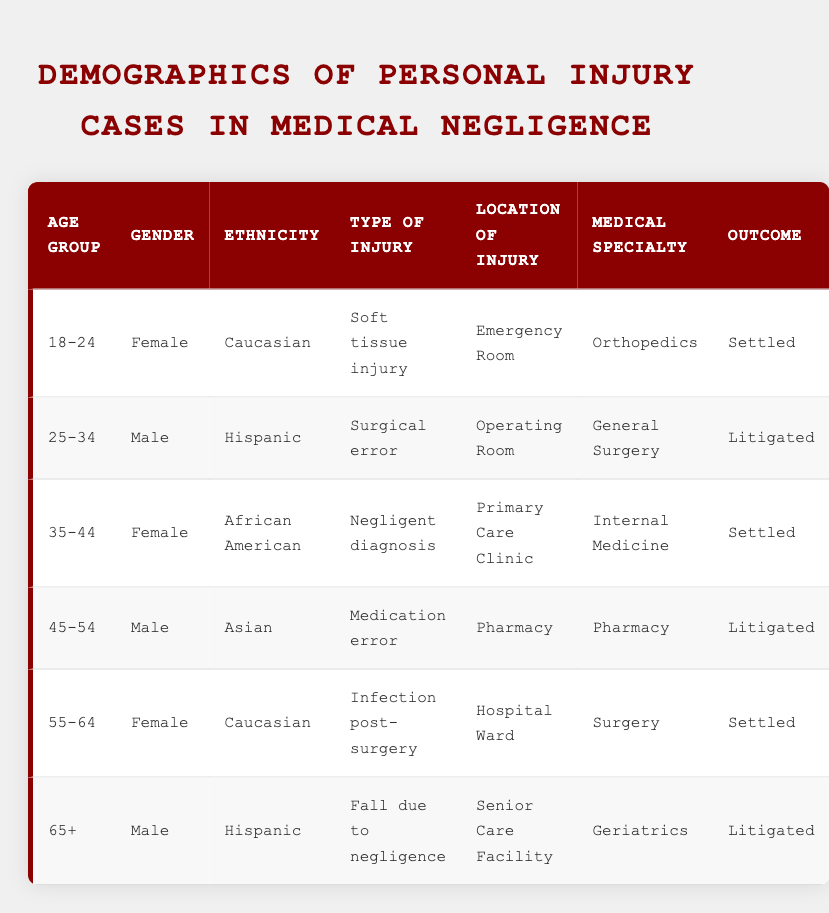What is the most common type of injury listed in the table? The table lists various types of injuries for patients involved in personal injury cases. By examining each entry, we find that "Settled" cases include "Soft tissue injury," "Negligent diagnosis," and "Infection post-surgery." There are three instances of "Settled" outcomes, but there are only two distinct types of injuries amongst "Litigated" cases. Thus, the most common type is "Settled."
Answer: Settled Which age group has the highest number of litigated cases? The table contains two "Litigated" cases: one for the age group "25-34" and another for the age group "65+." Therefore, both age groups have one case each, but there is no other age group listed. Hence, the highest number of litigated cases belongs to both age groups.
Answer: 25-34 and 65+ Is it true that all cases involving females resulted in a settled outcome? In the table, there are three cases involving females: one is "Settled" (Soft tissue injury), one is "Settled" (Infection post-surgery), and the other (35-44 age group) is also "Settled." Since both female cases resulted in a settled outcome, the statement is true.
Answer: Yes What is the ethnic diversity of the patients in the age group 55-64? The age group 55-64 is represented by one patient who is "Female" and "Caucasian." Since there is only one entry for that age group, the ethnic diversity is limited to Caucasian in this instance.
Answer: Caucasian How many males are involved in litigated cases and what types of injuries are associated with them? There are two males involved in litigated cases: one in the age group of 25-34 with a "Surgical error" and the other in the age group of 65+ with "Fall due to negligence." Therefore, in total, there are two males with their respective injuries specified.
Answer: 2 males: Surgical error and Fall due to negligence What is the average age of patients sustaining injuries in the "Settled" category? The patients with a "Settled" outcome are from the age groups "18-24" (22), "35-44" (39), and "55-64" (59). To find the average, we sum their ages: 22 + 39 + 59 = 120, then divide by 3, resulting in an average age of 40.
Answer: 40 In which medical specialty is the highest percentage of settled outcomes present? By reviewing the table, we see that "Orthopedics" and "Internal Medicine" both have one settled case each, while "Surgery" also has "Infection post-surgery" as a settled case. Thus, we count three distinct specialties with settled outcomes, marking no dominant specialty.
Answer: No dominant specialty Is there a pattern in gender representation concerning the outcomes of the cases? In the table, females account for three settled cases, while males are involved in two litigated cases. Therefore, we observe a pattern in which females are linked solely to settled cases while males have both settlements and litigations, indicating a significant correlation.
Answer: Yes 